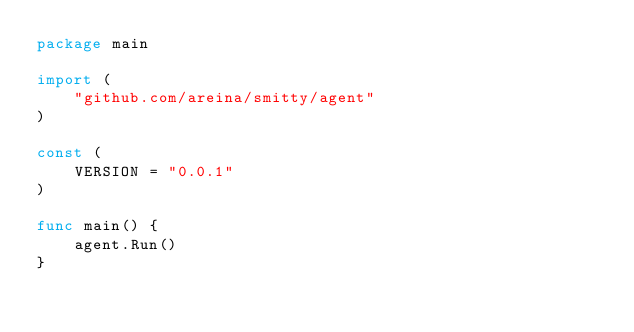Convert code to text. <code><loc_0><loc_0><loc_500><loc_500><_Go_>package main

import (
	"github.com/areina/smitty/agent"
)

const (
	VERSION = "0.0.1"
)

func main() {
	agent.Run()
}
</code> 